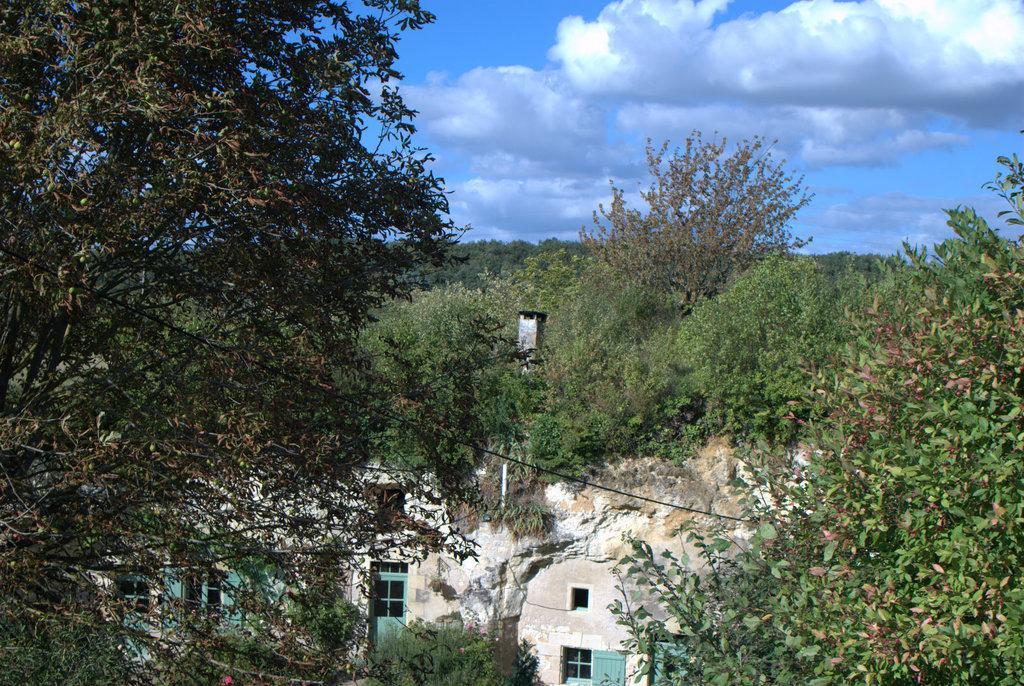Could you give a brief overview of what you see in this image? In this image there are trees, building, sky. 